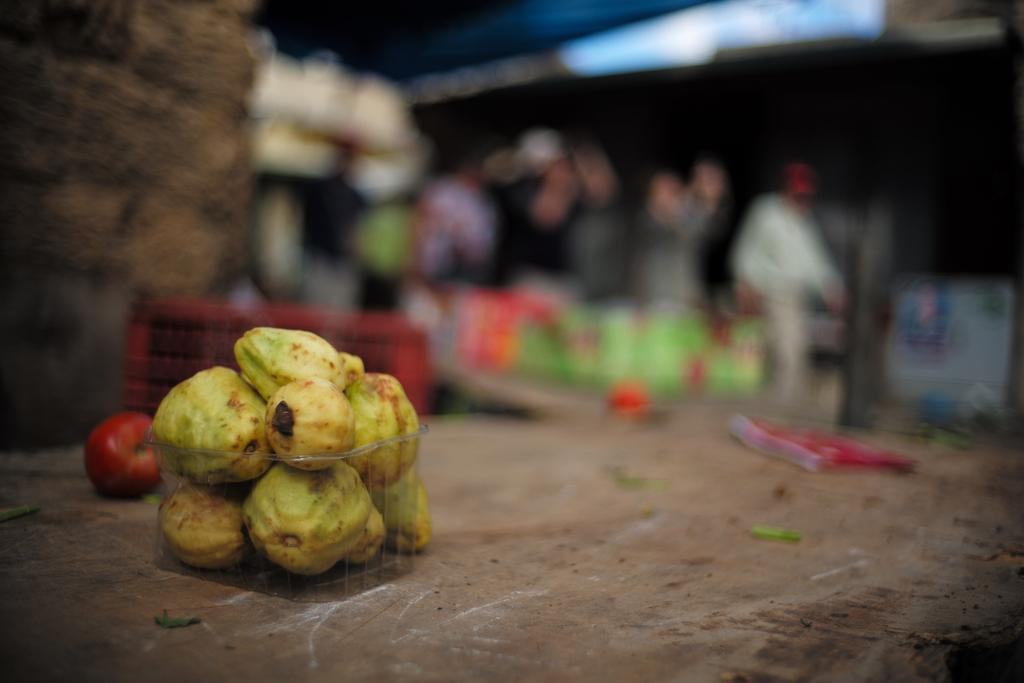What type of fruit is in the foreground of the image? There are guavas in the foreground of the image. Can you describe the background of the image? The background of the image is blurred. What type of farm can be seen in the background of the image? There is no farm visible in the image; the background is blurred. What brass objects are present in the image? There are no brass objects present in the image; it features guavas in the foreground and a blurred background. 